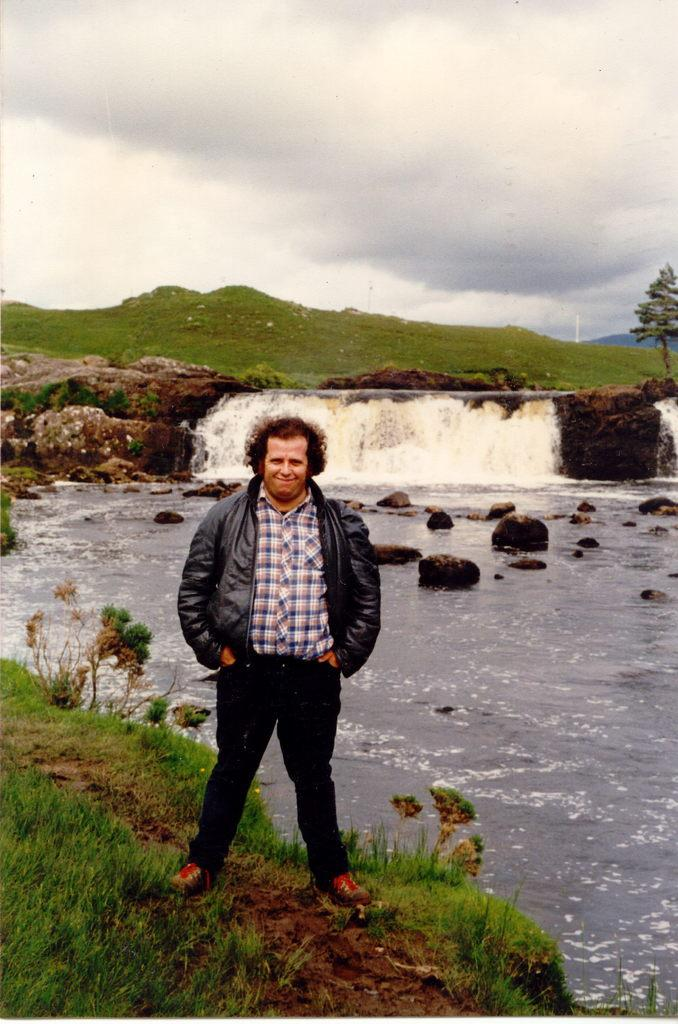What is the man doing in the image? The man is standing on the ground in the image. What is the man's facial expression? The man is smiling in the image. What type of vegetation can be seen in the image? There are plants, grass, and a tree visible in the image. What natural elements can be seen in the image? There is water, rocks, mountains, and clouds visible in the image. What part of the natural environment is visible in the background of the image? The sky is visible in the background of the image, with clouds present. How many people are in the crowd in the image? There is no crowd present in the image; it features a man standing on the ground with various natural elements and vegetation. What type of muscle is being exercised by the man in the image? There is no indication of the man exercising any muscles in the image; he is simply standing and smiling. 